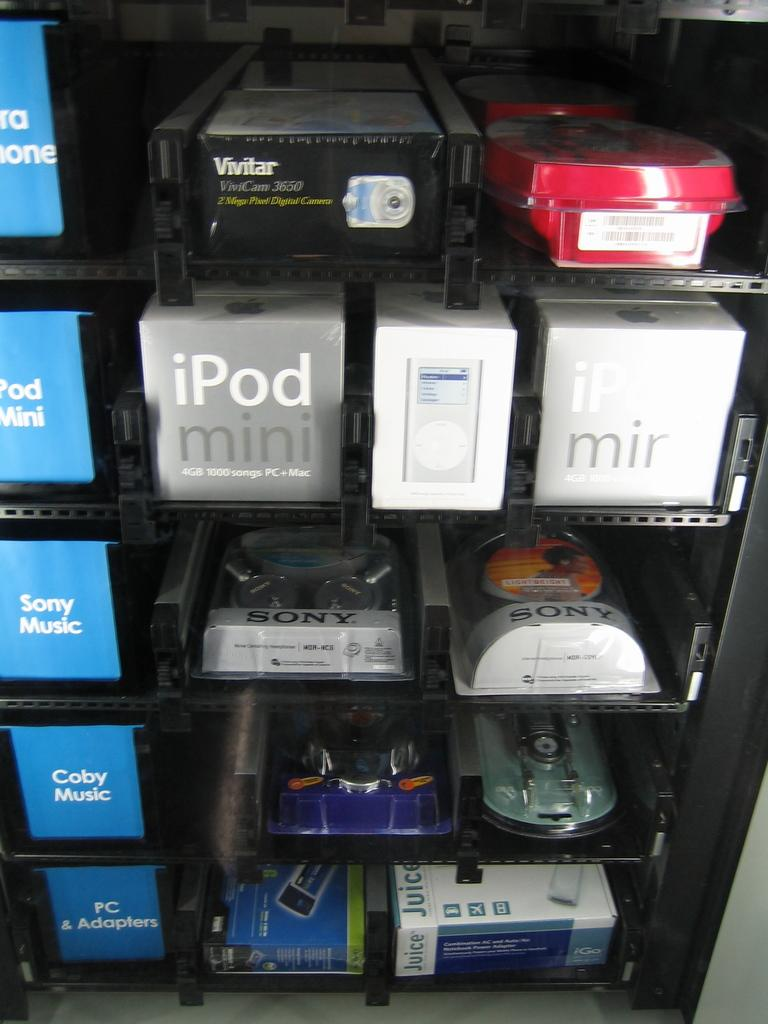What can be seen on the shelf in the image? There are objects arranged on a shelf in the image. What type of act is being performed by the objects on the shelf in the image? There is no act being performed by the objects on the shelf in the image, as they are simply arranged on the shelf. What kind of trouble are the objects on the shelf causing in the image? The objects on the shelf are not causing any trouble in the image; they are just arranged on the shelf. 